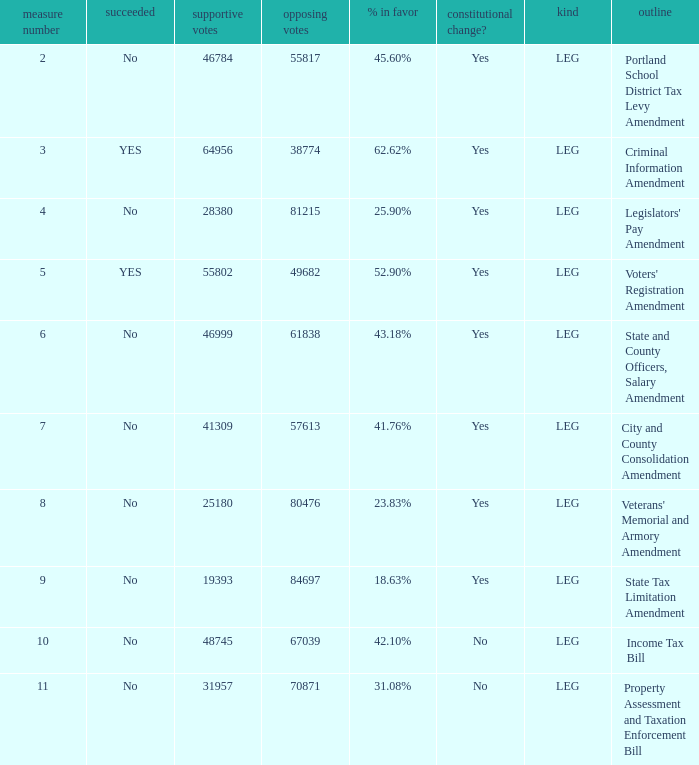Who had 41.76% yes votes City and County Consolidation Amendment. Give me the full table as a dictionary. {'header': ['measure number', 'succeeded', 'supportive votes', 'opposing votes', '% in favor', 'constitutional change?', 'kind', 'outline'], 'rows': [['2', 'No', '46784', '55817', '45.60%', 'Yes', 'LEG', 'Portland School District Tax Levy Amendment'], ['3', 'YES', '64956', '38774', '62.62%', 'Yes', 'LEG', 'Criminal Information Amendment'], ['4', 'No', '28380', '81215', '25.90%', 'Yes', 'LEG', "Legislators' Pay Amendment"], ['5', 'YES', '55802', '49682', '52.90%', 'Yes', 'LEG', "Voters' Registration Amendment"], ['6', 'No', '46999', '61838', '43.18%', 'Yes', 'LEG', 'State and County Officers, Salary Amendment'], ['7', 'No', '41309', '57613', '41.76%', 'Yes', 'LEG', 'City and County Consolidation Amendment'], ['8', 'No', '25180', '80476', '23.83%', 'Yes', 'LEG', "Veterans' Memorial and Armory Amendment"], ['9', 'No', '19393', '84697', '18.63%', 'Yes', 'LEG', 'State Tax Limitation Amendment'], ['10', 'No', '48745', '67039', '42.10%', 'No', 'LEG', 'Income Tax Bill'], ['11', 'No', '31957', '70871', '31.08%', 'No', 'LEG', 'Property Assessment and Taxation Enforcement Bill']]} 